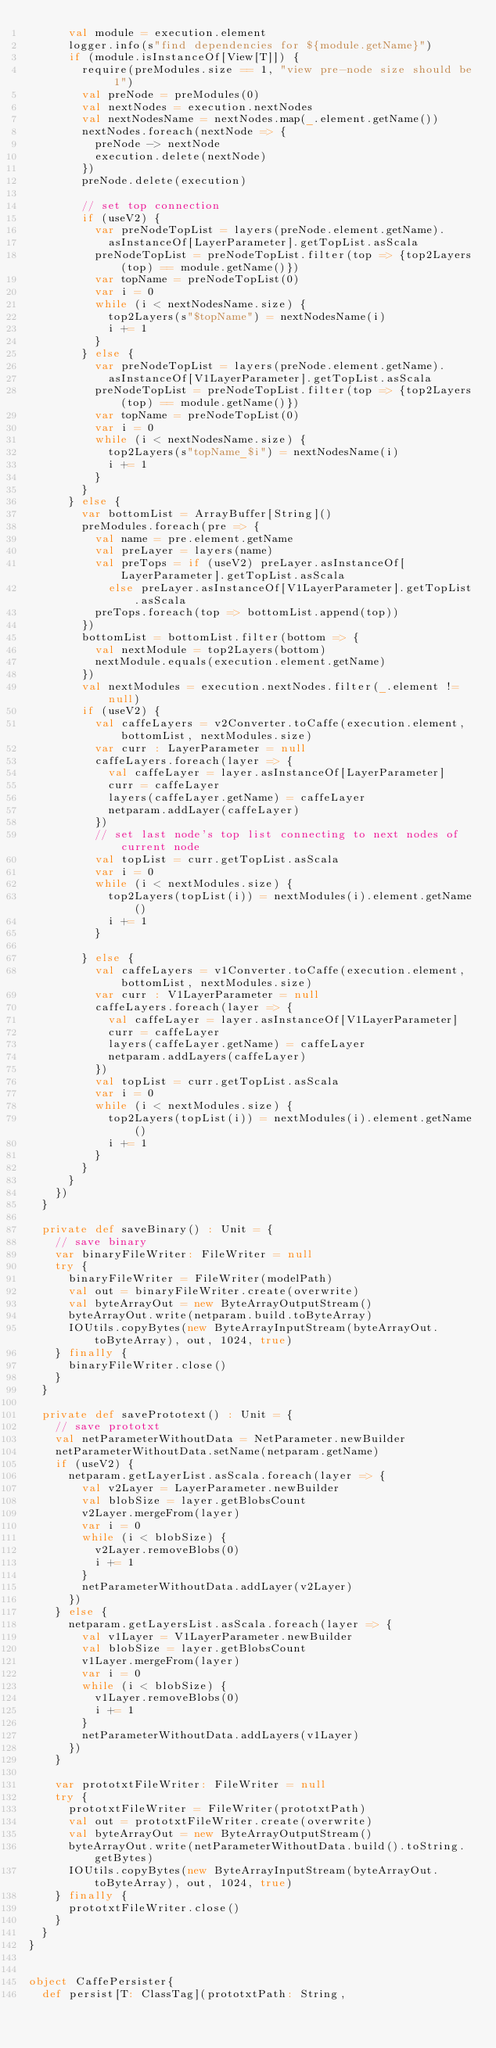<code> <loc_0><loc_0><loc_500><loc_500><_Scala_>      val module = execution.element
      logger.info(s"find dependencies for ${module.getName}")
      if (module.isInstanceOf[View[T]]) {
        require(preModules.size == 1, "view pre-node size should be 1")
        val preNode = preModules(0)
        val nextNodes = execution.nextNodes
        val nextNodesName = nextNodes.map(_.element.getName())
        nextNodes.foreach(nextNode => {
          preNode -> nextNode
          execution.delete(nextNode)
        })
        preNode.delete(execution)

        // set top connection
        if (useV2) {
          var preNodeTopList = layers(preNode.element.getName).
            asInstanceOf[LayerParameter].getTopList.asScala
          preNodeTopList = preNodeTopList.filter(top => {top2Layers(top) == module.getName()})
          var topName = preNodeTopList(0)
          var i = 0
          while (i < nextNodesName.size) {
            top2Layers(s"$topName") = nextNodesName(i)
            i += 1
          }
        } else {
          var preNodeTopList = layers(preNode.element.getName).
            asInstanceOf[V1LayerParameter].getTopList.asScala
          preNodeTopList = preNodeTopList.filter(top => {top2Layers(top) == module.getName()})
          var topName = preNodeTopList(0)
          var i = 0
          while (i < nextNodesName.size) {
            top2Layers(s"topName_$i") = nextNodesName(i)
            i += 1
          }
        }
      } else {
        var bottomList = ArrayBuffer[String]()
        preModules.foreach(pre => {
          val name = pre.element.getName
          val preLayer = layers(name)
          val preTops = if (useV2) preLayer.asInstanceOf[LayerParameter].getTopList.asScala
            else preLayer.asInstanceOf[V1LayerParameter].getTopList.asScala
          preTops.foreach(top => bottomList.append(top))
        })
        bottomList = bottomList.filter(bottom => {
          val nextModule = top2Layers(bottom)
          nextModule.equals(execution.element.getName)
        })
        val nextModules = execution.nextNodes.filter(_.element != null)
        if (useV2) {
          val caffeLayers = v2Converter.toCaffe(execution.element, bottomList, nextModules.size)
          var curr : LayerParameter = null
          caffeLayers.foreach(layer => {
            val caffeLayer = layer.asInstanceOf[LayerParameter]
            curr = caffeLayer
            layers(caffeLayer.getName) = caffeLayer
            netparam.addLayer(caffeLayer)
          })
          // set last node's top list connecting to next nodes of current node
          val topList = curr.getTopList.asScala
          var i = 0
          while (i < nextModules.size) {
            top2Layers(topList(i)) = nextModules(i).element.getName()
            i += 1
          }

        } else {
          val caffeLayers = v1Converter.toCaffe(execution.element, bottomList, nextModules.size)
          var curr : V1LayerParameter = null
          caffeLayers.foreach(layer => {
            val caffeLayer = layer.asInstanceOf[V1LayerParameter]
            curr = caffeLayer
            layers(caffeLayer.getName) = caffeLayer
            netparam.addLayers(caffeLayer)
          })
          val topList = curr.getTopList.asScala
          var i = 0
          while (i < nextModules.size) {
            top2Layers(topList(i)) = nextModules(i).element.getName()
            i += 1
          }
        }
      }
    })
  }

  private def saveBinary() : Unit = {
    // save binary
    var binaryFileWriter: FileWriter = null
    try {
      binaryFileWriter = FileWriter(modelPath)
      val out = binaryFileWriter.create(overwrite)
      val byteArrayOut = new ByteArrayOutputStream()
      byteArrayOut.write(netparam.build.toByteArray)
      IOUtils.copyBytes(new ByteArrayInputStream(byteArrayOut.toByteArray), out, 1024, true)
    } finally {
      binaryFileWriter.close()
    }
  }

  private def savePrototext() : Unit = {
    // save prototxt
    val netParameterWithoutData = NetParameter.newBuilder
    netParameterWithoutData.setName(netparam.getName)
    if (useV2) {
      netparam.getLayerList.asScala.foreach(layer => {
        val v2Layer = LayerParameter.newBuilder
        val blobSize = layer.getBlobsCount
        v2Layer.mergeFrom(layer)
        var i = 0
        while (i < blobSize) {
          v2Layer.removeBlobs(0)
          i += 1
        }
        netParameterWithoutData.addLayer(v2Layer)
      })
    } else {
      netparam.getLayersList.asScala.foreach(layer => {
        val v1Layer = V1LayerParameter.newBuilder
        val blobSize = layer.getBlobsCount
        v1Layer.mergeFrom(layer)
        var i = 0
        while (i < blobSize) {
          v1Layer.removeBlobs(0)
          i += 1
        }
        netParameterWithoutData.addLayers(v1Layer)
      })
    }

    var prototxtFileWriter: FileWriter = null
    try {
      prototxtFileWriter = FileWriter(prototxtPath)
      val out = prototxtFileWriter.create(overwrite)
      val byteArrayOut = new ByteArrayOutputStream()
      byteArrayOut.write(netParameterWithoutData.build().toString.getBytes)
      IOUtils.copyBytes(new ByteArrayInputStream(byteArrayOut.toByteArray), out, 1024, true)
    } finally {
      prototxtFileWriter.close()
    }
  }
}


object CaffePersister{
  def persist[T: ClassTag](prototxtPath: String,</code> 